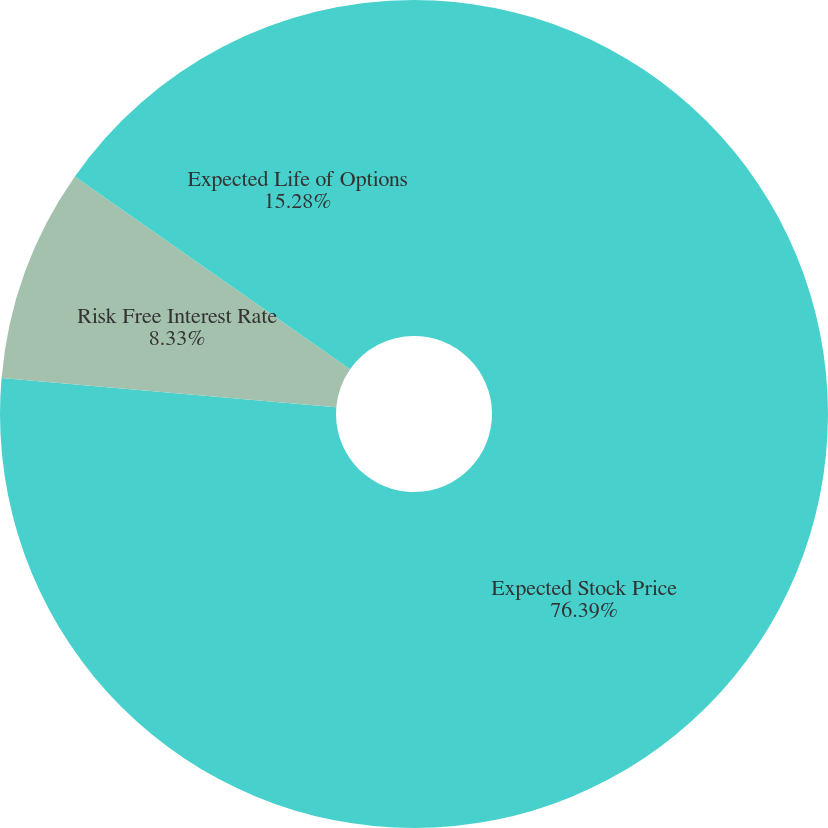Convert chart to OTSL. <chart><loc_0><loc_0><loc_500><loc_500><pie_chart><fcel>Expected Stock Price<fcel>Risk Free Interest Rate<fcel>Expected Life of Options<nl><fcel>76.39%<fcel>8.33%<fcel>15.28%<nl></chart> 